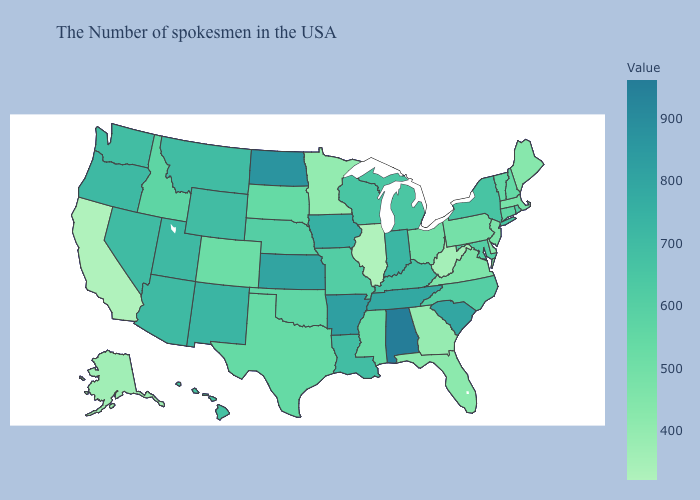Does the map have missing data?
Give a very brief answer. No. Does Illinois have the lowest value in the MidWest?
Answer briefly. Yes. Is the legend a continuous bar?
Write a very short answer. Yes. Does Nevada have the highest value in the USA?
Be succinct. No. Which states have the lowest value in the USA?
Short answer required. Illinois, California. Which states have the highest value in the USA?
Answer briefly. Alabama. Does Maine have the highest value in the Northeast?
Concise answer only. No. 